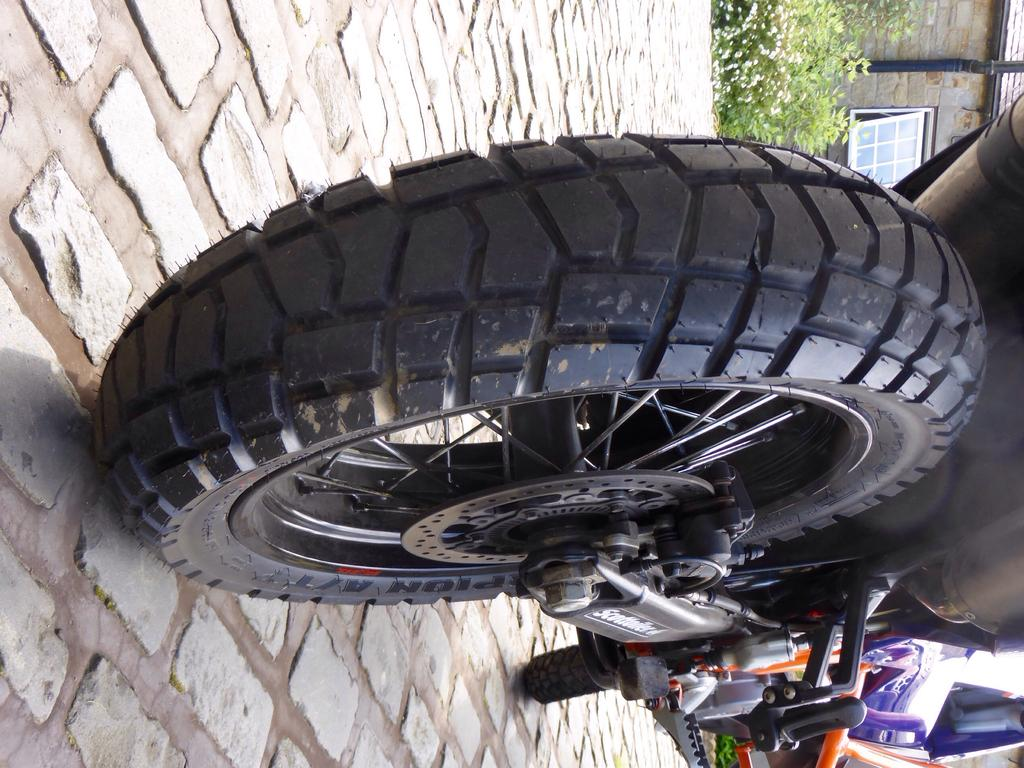What type of vehicle is in the image? There is a motorbike in the image. What color is the motorbike? The motorbike is black in color. Where is the motorbike located in the image? The motorbike is on the ground. What type of vegetation can be seen in the image? There are plants and flowers in the image. What is visible in the background of the image? There is a building and the sky in the background of the image. What type of teeth can be seen on the motorbike in the image? There are no teeth present on the motorbike in the image. Where is the bucket located in the image? There is no bucket present in the image. 